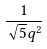<formula> <loc_0><loc_0><loc_500><loc_500>\frac { 1 } { \sqrt { 5 } q ^ { 2 } }</formula> 